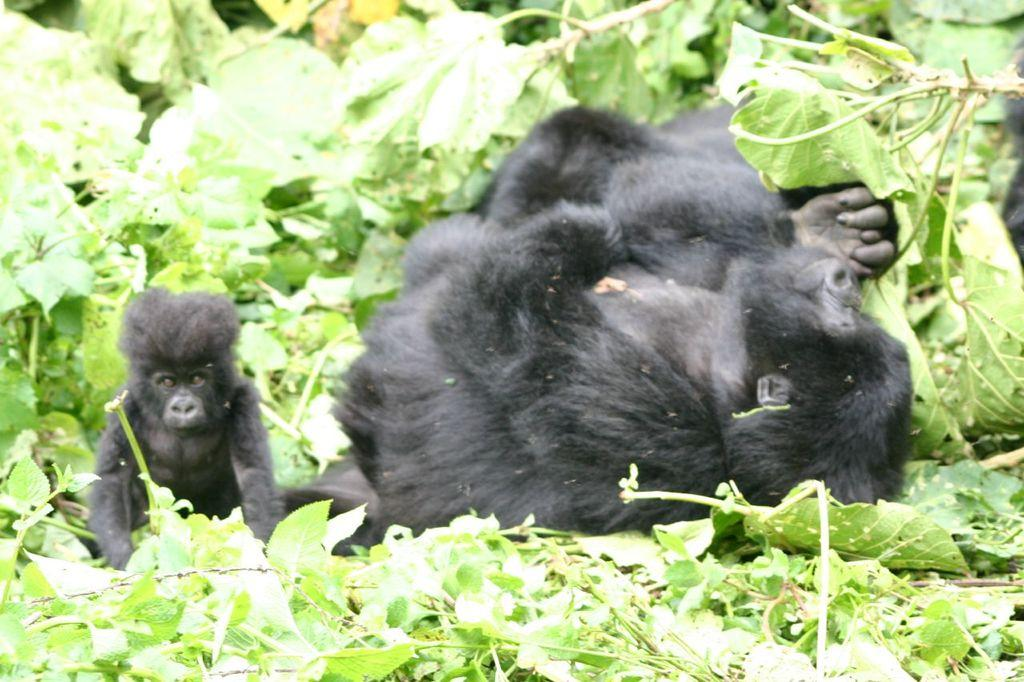What is the main subject of the image? There is an animal lying on the ground in the image. Are there any other animals present in the image? Yes, there is another animal beside the first animal. What can be seen in the background of the image? There are green plants in the background of the image. What type of bridge can be seen in the image? There is no bridge present in the image. What color is the shirt worn by the animal in the image? The image does not show any animals wearing shirts, and animals typically do not wear clothing. 